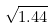Convert formula to latex. <formula><loc_0><loc_0><loc_500><loc_500>\sqrt { 1 . 4 4 }</formula> 